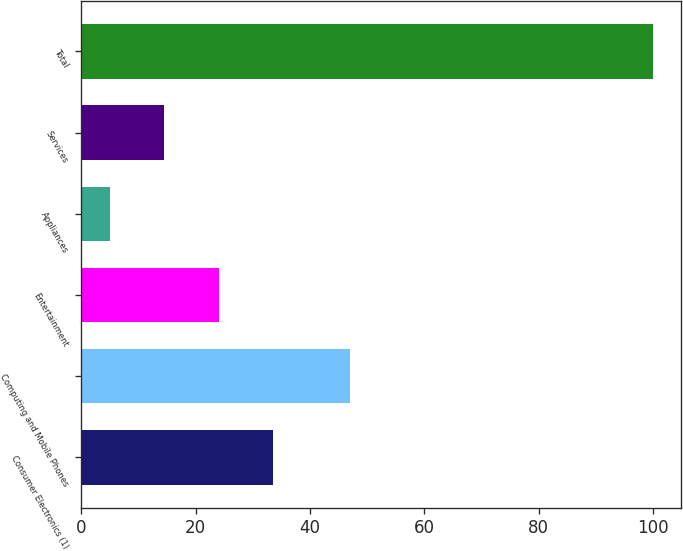Convert chart. <chart><loc_0><loc_0><loc_500><loc_500><bar_chart><fcel>Consumer Electronics (1)<fcel>Computing and Mobile Phones<fcel>Entertainment<fcel>Appliances<fcel>Services<fcel>Total<nl><fcel>33.5<fcel>47<fcel>24<fcel>5<fcel>14.5<fcel>100<nl></chart> 